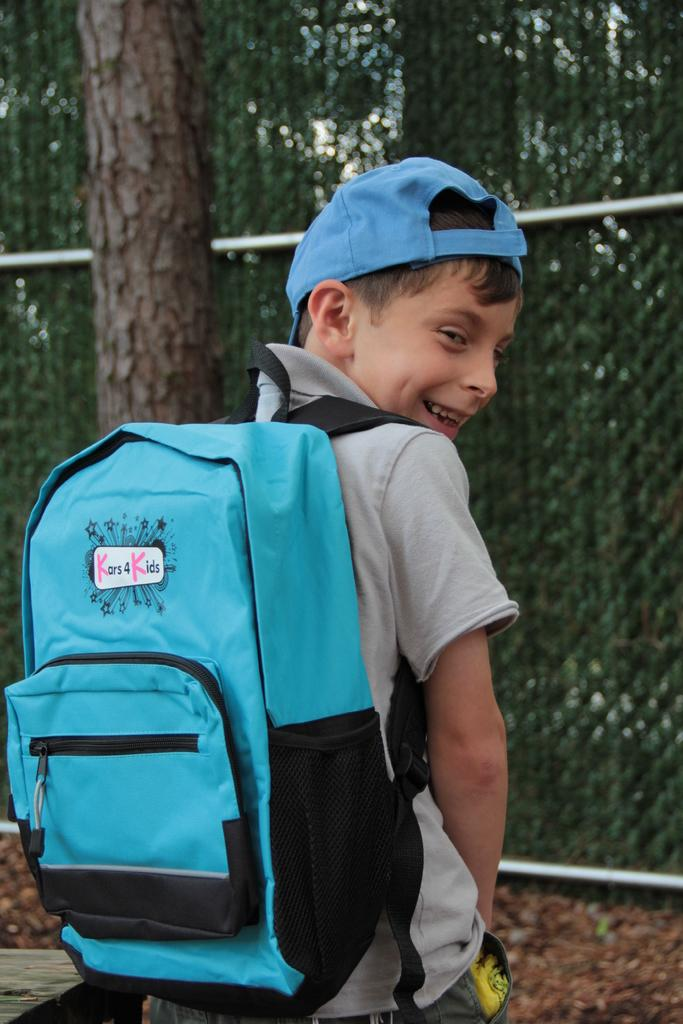<image>
Present a compact description of the photo's key features. Boy wearing a blue Kars 4 Kids backpack. 